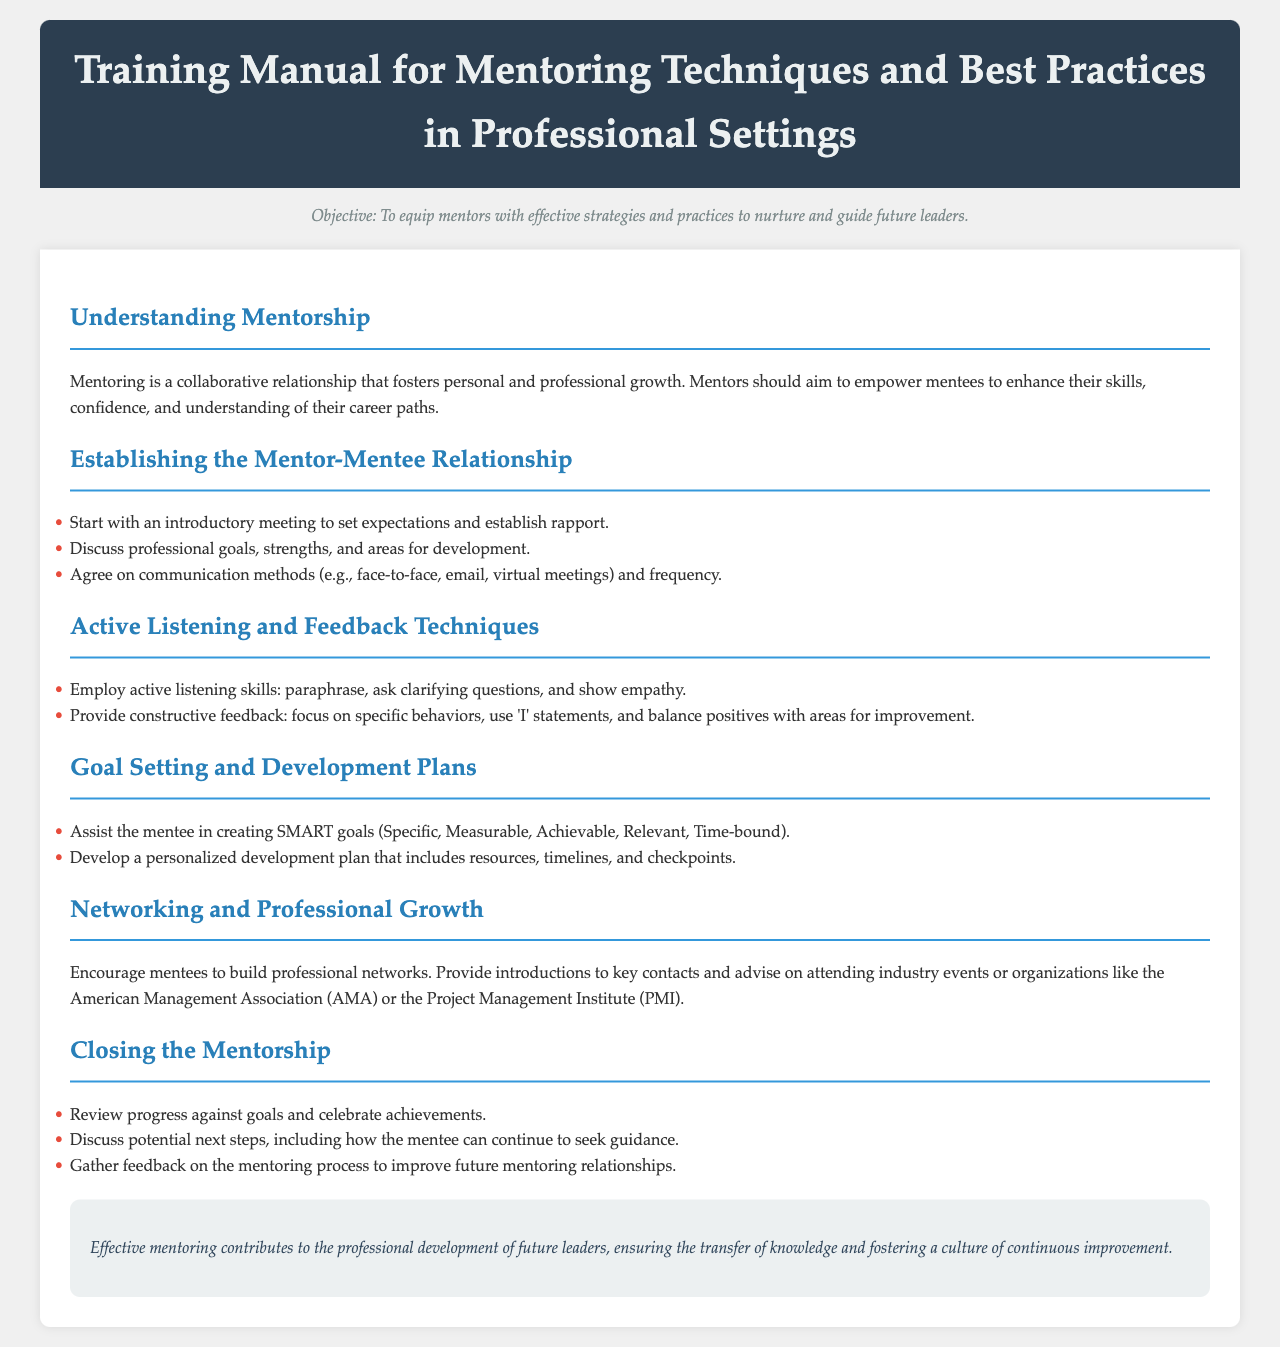What is the objective of the manual? The objective of the manual is to equip mentors with effective strategies and practices to nurture and guide future leaders.
Answer: To equip mentors with effective strategies and practices to nurture and guide future leaders What section discusses communication methods? The section that discusses communication methods is "Establishing the Mentor-Mentee Relationship."
Answer: Establishing the Mentor-Mentee Relationship What are the SMART goals? SMART goals are described as Specific, Measurable, Achievable, Relevant, and Time-bound.
Answer: Specific, Measurable, Achievable, Relevant, Time-bound How should feedback be provided according to the manual? Feedback should focus on specific behaviors, use 'I' statements, and balance positives with areas for improvement.
Answer: Focus on specific behaviors, use 'I' statements, and balance positives with areas for improvement What is a technique recommended for listening actively? A recommended technique for listening actively is to paraphrase.
Answer: Paraphrase What organization is mentioned for networking opportunities? The organization mentioned for networking opportunities is the American Management Association (AMA).
Answer: American Management Association (AMA) What should be celebrated at the end of mentorship? At the end of mentorship, achievements should be celebrated.
Answer: Achievements What is a key focus of the "Networking and Professional Growth" section? The key focus is to encourage mentees to build professional networks.
Answer: Encourage mentees to build professional networks 